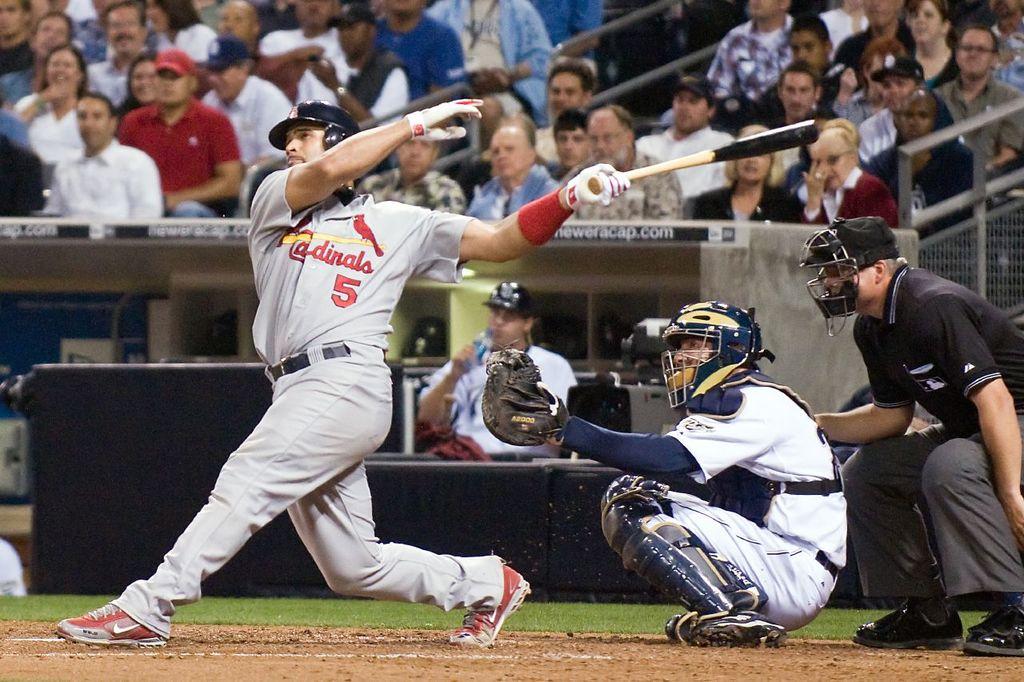What team is this?
Your answer should be compact. Cardinals. 